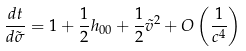<formula> <loc_0><loc_0><loc_500><loc_500>\frac { d t } { d \tilde { \sigma } } = 1 + \frac { 1 } { 2 } h _ { 0 0 } + \frac { 1 } { 2 } \tilde { v } ^ { 2 } + O \left ( \frac { 1 } { c ^ { 4 } } \right )</formula> 